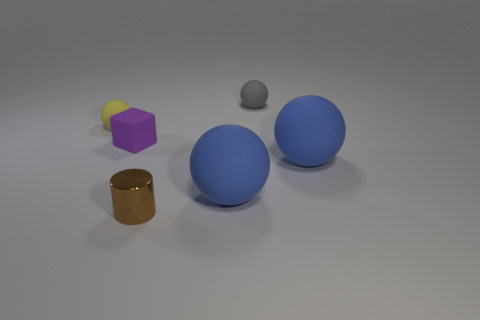Does the tiny matte object right of the tiny purple thing have the same shape as the purple rubber object that is on the left side of the brown metallic thing?
Make the answer very short. No. There is a thing that is both on the right side of the yellow thing and on the left side of the tiny metallic object; what color is it?
Your answer should be very brief. Purple. Do the object that is behind the yellow rubber object and the blue object to the right of the small gray matte ball have the same size?
Offer a very short reply. No. How many big spheres are the same color as the tiny matte cube?
Your answer should be compact. 0. What number of small things are either yellow rubber spheres or brown blocks?
Your answer should be very brief. 1. Are the large thing that is left of the small gray rubber object and the purple thing made of the same material?
Your answer should be compact. Yes. What color is the tiny rubber ball that is on the left side of the matte block?
Make the answer very short. Yellow. Is there a purple matte thing of the same size as the gray matte object?
Your answer should be compact. Yes. What material is the gray sphere that is the same size as the shiny cylinder?
Give a very brief answer. Rubber. Does the matte block have the same size as the blue rubber object that is to the left of the small gray object?
Make the answer very short. No. 